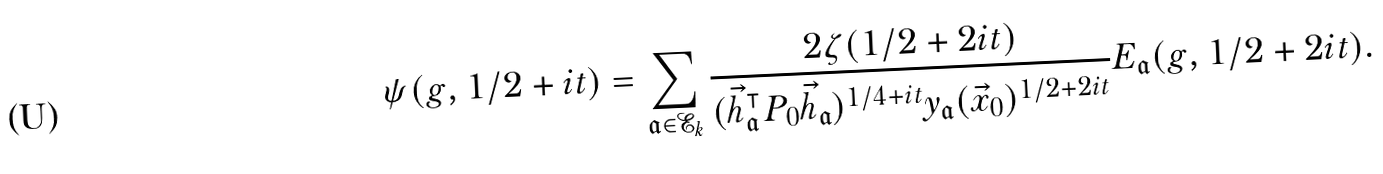Convert formula to latex. <formula><loc_0><loc_0><loc_500><loc_500>\psi ( g , 1 / 2 + i t ) = \sum _ { \mathfrak { a } \in \mathcal { E } _ { k } } \frac { 2 \zeta ( 1 / 2 + 2 i t ) } { ( \vec { h } _ { \mathfrak { a } } ^ { \intercal } P _ { 0 } \vec { h } _ { \mathfrak { a } } ) ^ { 1 / 4 + i t } y _ { \mathfrak { a } } ( \vec { x } _ { 0 } ) ^ { 1 / 2 + 2 i t } } E _ { \mathfrak { a } } ( g , 1 / 2 + 2 i t ) .</formula> 